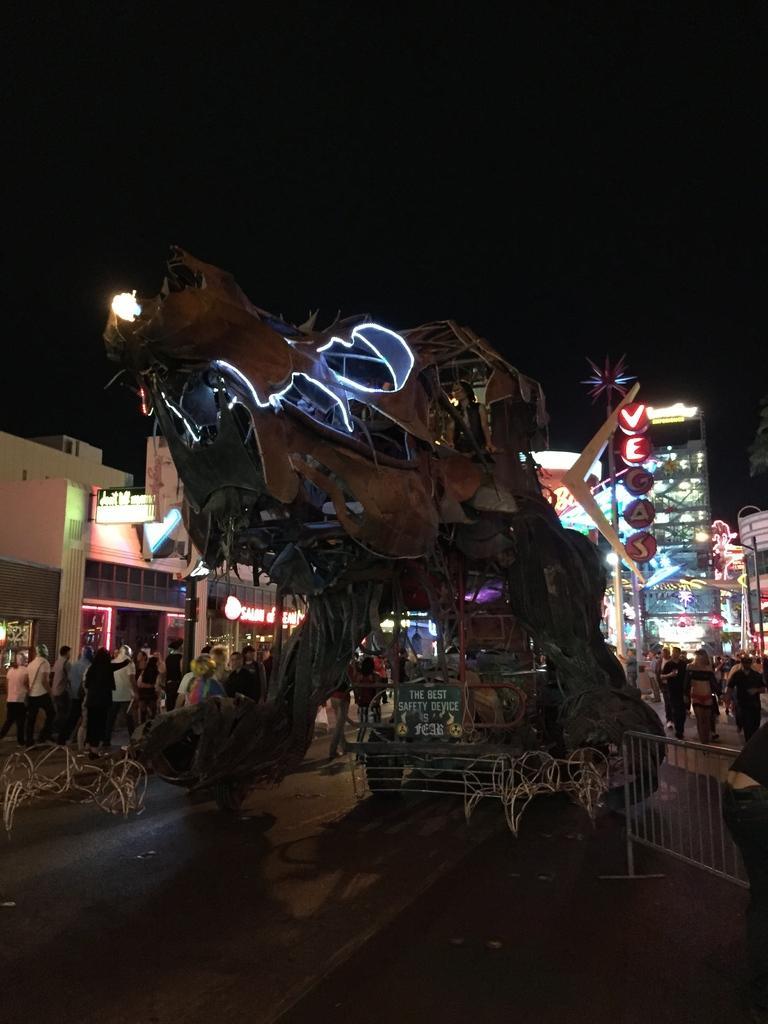Describe this image in one or two sentences. In this image we can see some different structure of a vehicle which is on the road and in the background of the image there are some persons walking there are some shops, houses and top of the image there is clear sky. 